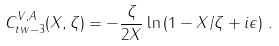<formula> <loc_0><loc_0><loc_500><loc_500>C ^ { V , A } _ { t w - 3 } ( X , \zeta ) = - \frac { \zeta } { 2 X } \ln \left ( 1 - X / \zeta + i \epsilon \right ) \, .</formula> 